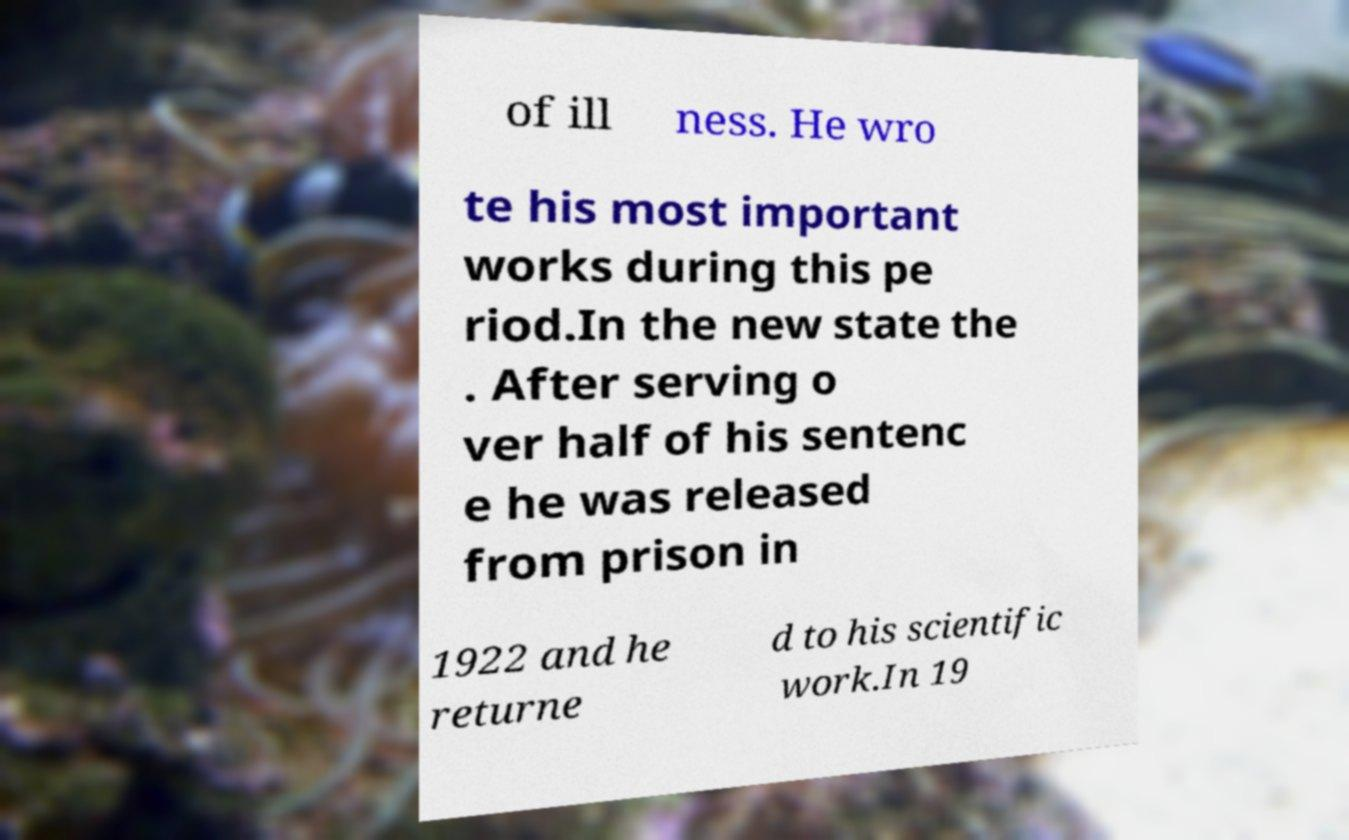For documentation purposes, I need the text within this image transcribed. Could you provide that? of ill ness. He wro te his most important works during this pe riod.In the new state the . After serving o ver half of his sentenc e he was released from prison in 1922 and he returne d to his scientific work.In 19 